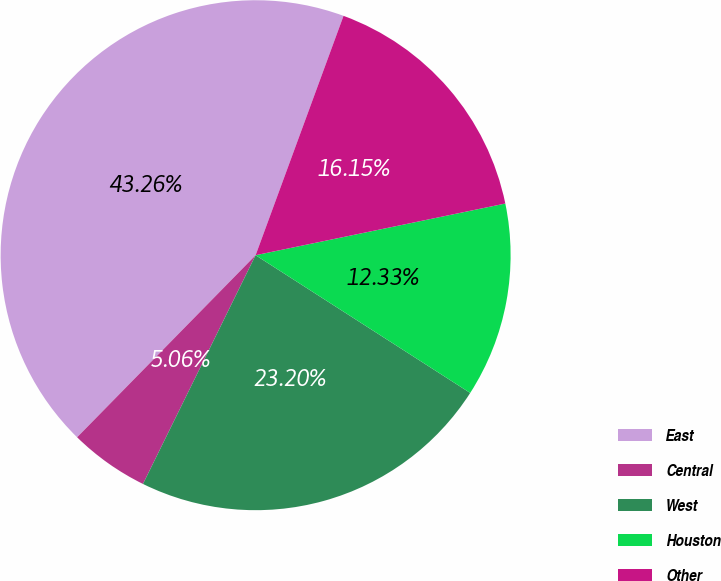<chart> <loc_0><loc_0><loc_500><loc_500><pie_chart><fcel>East<fcel>Central<fcel>West<fcel>Houston<fcel>Other<nl><fcel>43.26%<fcel>5.06%<fcel>23.2%<fcel>12.33%<fcel>16.15%<nl></chart> 